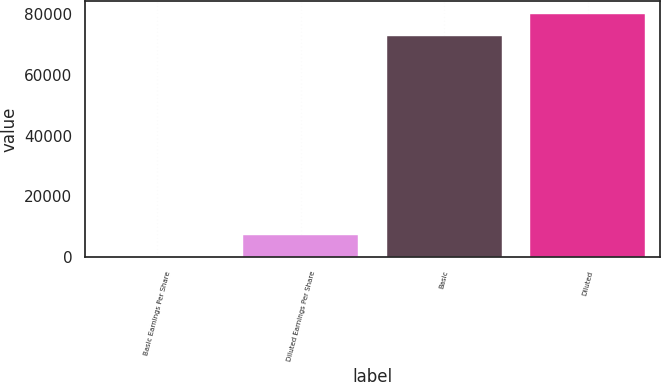<chart> <loc_0><loc_0><loc_500><loc_500><bar_chart><fcel>Basic Earnings Per Share<fcel>Diluted Earnings Per Share<fcel>Basic<fcel>Diluted<nl><fcel>0.31<fcel>7290.18<fcel>72899<fcel>80188.9<nl></chart> 